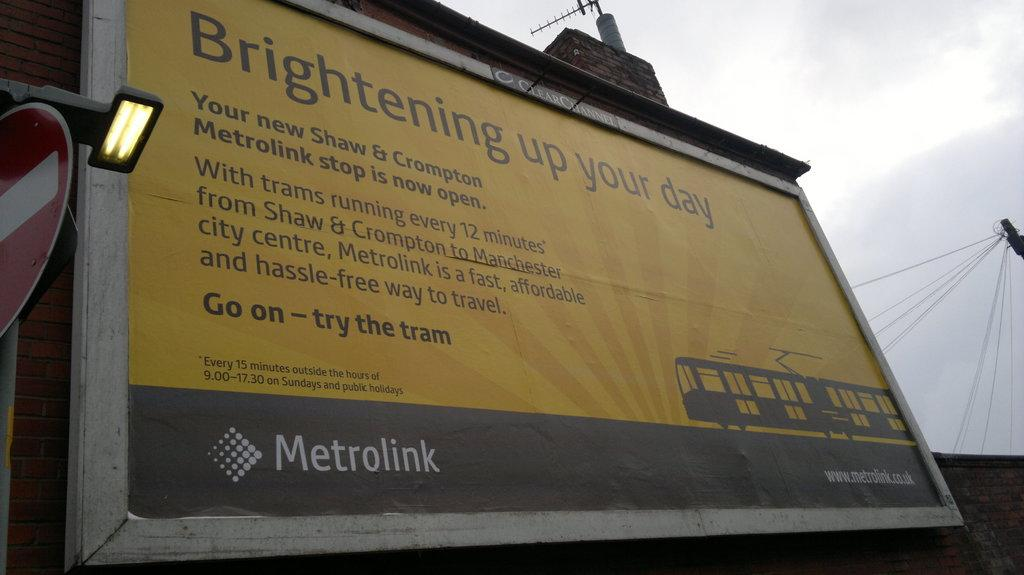<image>
Create a compact narrative representing the image presented. A Metrolink billboard with the phrase "Brightening up your day" at the top. 